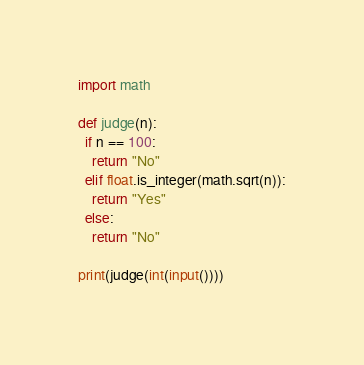<code> <loc_0><loc_0><loc_500><loc_500><_Python_>import math

def judge(n):
  if n == 100:
    return "No"
  elif float.is_integer(math.sqrt(n)):
    return "Yes"
  else:
    return "No"
  
print(judge(int(input())))
</code> 